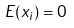<formula> <loc_0><loc_0><loc_500><loc_500>E ( x _ { i } ) = 0</formula> 